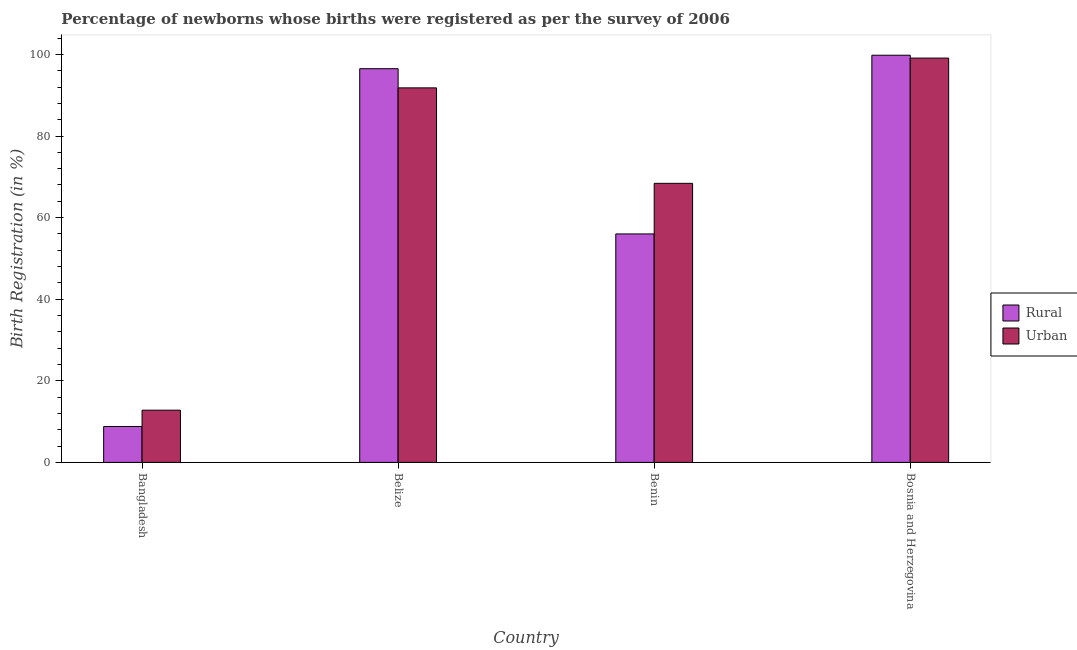How many different coloured bars are there?
Your answer should be very brief. 2. How many groups of bars are there?
Your answer should be compact. 4. Are the number of bars per tick equal to the number of legend labels?
Provide a succinct answer. Yes. How many bars are there on the 2nd tick from the left?
Provide a succinct answer. 2. What is the label of the 4th group of bars from the left?
Provide a succinct answer. Bosnia and Herzegovina. What is the rural birth registration in Belize?
Your answer should be compact. 96.5. Across all countries, what is the maximum urban birth registration?
Ensure brevity in your answer.  99.1. Across all countries, what is the minimum urban birth registration?
Keep it short and to the point. 12.8. In which country was the rural birth registration maximum?
Give a very brief answer. Bosnia and Herzegovina. What is the total urban birth registration in the graph?
Provide a succinct answer. 272.1. What is the difference between the urban birth registration in Bangladesh and that in Belize?
Offer a very short reply. -79. What is the difference between the rural birth registration in Benin and the urban birth registration in Bosnia and Herzegovina?
Offer a terse response. -43.1. What is the average rural birth registration per country?
Provide a short and direct response. 65.28. In how many countries, is the urban birth registration greater than 20 %?
Provide a succinct answer. 3. What is the ratio of the urban birth registration in Benin to that in Bosnia and Herzegovina?
Keep it short and to the point. 0.69. Is the urban birth registration in Bangladesh less than that in Belize?
Ensure brevity in your answer.  Yes. Is the difference between the rural birth registration in Belize and Benin greater than the difference between the urban birth registration in Belize and Benin?
Make the answer very short. Yes. What is the difference between the highest and the second highest urban birth registration?
Offer a terse response. 7.3. What is the difference between the highest and the lowest rural birth registration?
Your response must be concise. 91. In how many countries, is the rural birth registration greater than the average rural birth registration taken over all countries?
Keep it short and to the point. 2. What does the 2nd bar from the left in Bosnia and Herzegovina represents?
Offer a terse response. Urban. What does the 1st bar from the right in Benin represents?
Your answer should be very brief. Urban. How many bars are there?
Make the answer very short. 8. Are all the bars in the graph horizontal?
Provide a short and direct response. No. How many countries are there in the graph?
Your response must be concise. 4. Are the values on the major ticks of Y-axis written in scientific E-notation?
Keep it short and to the point. No. Does the graph contain any zero values?
Give a very brief answer. No. Where does the legend appear in the graph?
Ensure brevity in your answer.  Center right. What is the title of the graph?
Offer a terse response. Percentage of newborns whose births were registered as per the survey of 2006. What is the label or title of the Y-axis?
Your answer should be compact. Birth Registration (in %). What is the Birth Registration (in %) in Rural in Bangladesh?
Provide a short and direct response. 8.8. What is the Birth Registration (in %) in Urban in Bangladesh?
Offer a very short reply. 12.8. What is the Birth Registration (in %) of Rural in Belize?
Make the answer very short. 96.5. What is the Birth Registration (in %) in Urban in Belize?
Provide a short and direct response. 91.8. What is the Birth Registration (in %) in Urban in Benin?
Your answer should be very brief. 68.4. What is the Birth Registration (in %) in Rural in Bosnia and Herzegovina?
Ensure brevity in your answer.  99.8. What is the Birth Registration (in %) in Urban in Bosnia and Herzegovina?
Ensure brevity in your answer.  99.1. Across all countries, what is the maximum Birth Registration (in %) of Rural?
Offer a very short reply. 99.8. Across all countries, what is the maximum Birth Registration (in %) in Urban?
Give a very brief answer. 99.1. What is the total Birth Registration (in %) of Rural in the graph?
Provide a short and direct response. 261.1. What is the total Birth Registration (in %) in Urban in the graph?
Keep it short and to the point. 272.1. What is the difference between the Birth Registration (in %) in Rural in Bangladesh and that in Belize?
Your answer should be compact. -87.7. What is the difference between the Birth Registration (in %) in Urban in Bangladesh and that in Belize?
Your response must be concise. -79. What is the difference between the Birth Registration (in %) of Rural in Bangladesh and that in Benin?
Give a very brief answer. -47.2. What is the difference between the Birth Registration (in %) in Urban in Bangladesh and that in Benin?
Your response must be concise. -55.6. What is the difference between the Birth Registration (in %) in Rural in Bangladesh and that in Bosnia and Herzegovina?
Make the answer very short. -91. What is the difference between the Birth Registration (in %) in Urban in Bangladesh and that in Bosnia and Herzegovina?
Give a very brief answer. -86.3. What is the difference between the Birth Registration (in %) of Rural in Belize and that in Benin?
Offer a terse response. 40.5. What is the difference between the Birth Registration (in %) in Urban in Belize and that in Benin?
Give a very brief answer. 23.4. What is the difference between the Birth Registration (in %) in Urban in Belize and that in Bosnia and Herzegovina?
Provide a succinct answer. -7.3. What is the difference between the Birth Registration (in %) in Rural in Benin and that in Bosnia and Herzegovina?
Your answer should be very brief. -43.8. What is the difference between the Birth Registration (in %) in Urban in Benin and that in Bosnia and Herzegovina?
Provide a short and direct response. -30.7. What is the difference between the Birth Registration (in %) in Rural in Bangladesh and the Birth Registration (in %) in Urban in Belize?
Your answer should be compact. -83. What is the difference between the Birth Registration (in %) of Rural in Bangladesh and the Birth Registration (in %) of Urban in Benin?
Provide a succinct answer. -59.6. What is the difference between the Birth Registration (in %) in Rural in Bangladesh and the Birth Registration (in %) in Urban in Bosnia and Herzegovina?
Make the answer very short. -90.3. What is the difference between the Birth Registration (in %) of Rural in Belize and the Birth Registration (in %) of Urban in Benin?
Your answer should be compact. 28.1. What is the difference between the Birth Registration (in %) of Rural in Belize and the Birth Registration (in %) of Urban in Bosnia and Herzegovina?
Provide a succinct answer. -2.6. What is the difference between the Birth Registration (in %) in Rural in Benin and the Birth Registration (in %) in Urban in Bosnia and Herzegovina?
Your answer should be compact. -43.1. What is the average Birth Registration (in %) in Rural per country?
Your answer should be compact. 65.28. What is the average Birth Registration (in %) of Urban per country?
Keep it short and to the point. 68.03. What is the ratio of the Birth Registration (in %) in Rural in Bangladesh to that in Belize?
Your response must be concise. 0.09. What is the ratio of the Birth Registration (in %) of Urban in Bangladesh to that in Belize?
Offer a very short reply. 0.14. What is the ratio of the Birth Registration (in %) of Rural in Bangladesh to that in Benin?
Your answer should be compact. 0.16. What is the ratio of the Birth Registration (in %) in Urban in Bangladesh to that in Benin?
Offer a very short reply. 0.19. What is the ratio of the Birth Registration (in %) in Rural in Bangladesh to that in Bosnia and Herzegovina?
Offer a very short reply. 0.09. What is the ratio of the Birth Registration (in %) of Urban in Bangladesh to that in Bosnia and Herzegovina?
Give a very brief answer. 0.13. What is the ratio of the Birth Registration (in %) of Rural in Belize to that in Benin?
Provide a succinct answer. 1.72. What is the ratio of the Birth Registration (in %) in Urban in Belize to that in Benin?
Your answer should be compact. 1.34. What is the ratio of the Birth Registration (in %) of Rural in Belize to that in Bosnia and Herzegovina?
Make the answer very short. 0.97. What is the ratio of the Birth Registration (in %) of Urban in Belize to that in Bosnia and Herzegovina?
Offer a very short reply. 0.93. What is the ratio of the Birth Registration (in %) of Rural in Benin to that in Bosnia and Herzegovina?
Your answer should be compact. 0.56. What is the ratio of the Birth Registration (in %) of Urban in Benin to that in Bosnia and Herzegovina?
Make the answer very short. 0.69. What is the difference between the highest and the second highest Birth Registration (in %) of Rural?
Offer a very short reply. 3.3. What is the difference between the highest and the second highest Birth Registration (in %) of Urban?
Your answer should be very brief. 7.3. What is the difference between the highest and the lowest Birth Registration (in %) in Rural?
Your answer should be compact. 91. What is the difference between the highest and the lowest Birth Registration (in %) of Urban?
Offer a very short reply. 86.3. 